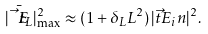<formula> <loc_0><loc_0><loc_500><loc_500>| \bar { \vec { t } { E } } _ { L } | _ { \max } ^ { 2 } \approx ( 1 + \delta _ { L } L ^ { 2 } ) \, | \vec { t } { E } _ { i } n | ^ { 2 } .</formula> 